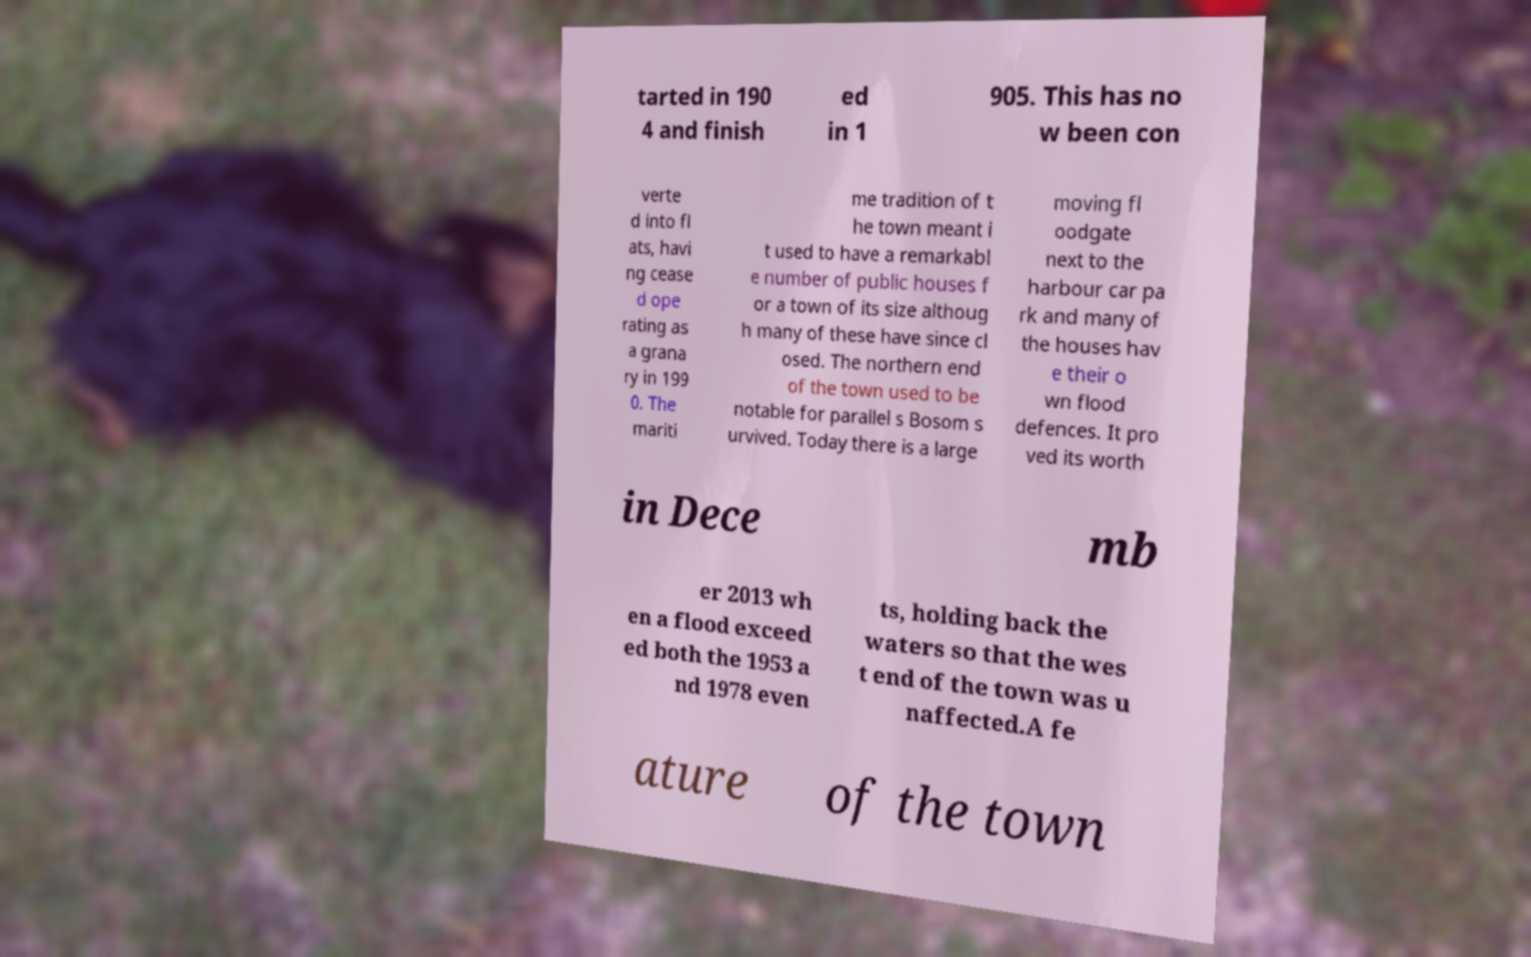Can you accurately transcribe the text from the provided image for me? tarted in 190 4 and finish ed in 1 905. This has no w been con verte d into fl ats, havi ng cease d ope rating as a grana ry in 199 0. The mariti me tradition of t he town meant i t used to have a remarkabl e number of public houses f or a town of its size althoug h many of these have since cl osed. The northern end of the town used to be notable for parallel s Bosom s urvived. Today there is a large moving fl oodgate next to the harbour car pa rk and many of the houses hav e their o wn flood defences. It pro ved its worth in Dece mb er 2013 wh en a flood exceed ed both the 1953 a nd 1978 even ts, holding back the waters so that the wes t end of the town was u naffected.A fe ature of the town 